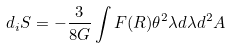Convert formula to latex. <formula><loc_0><loc_0><loc_500><loc_500>d _ { i } S = - \frac { 3 } { 8 G } \int F ( R ) \theta ^ { 2 } \lambda d \lambda d ^ { 2 } A</formula> 